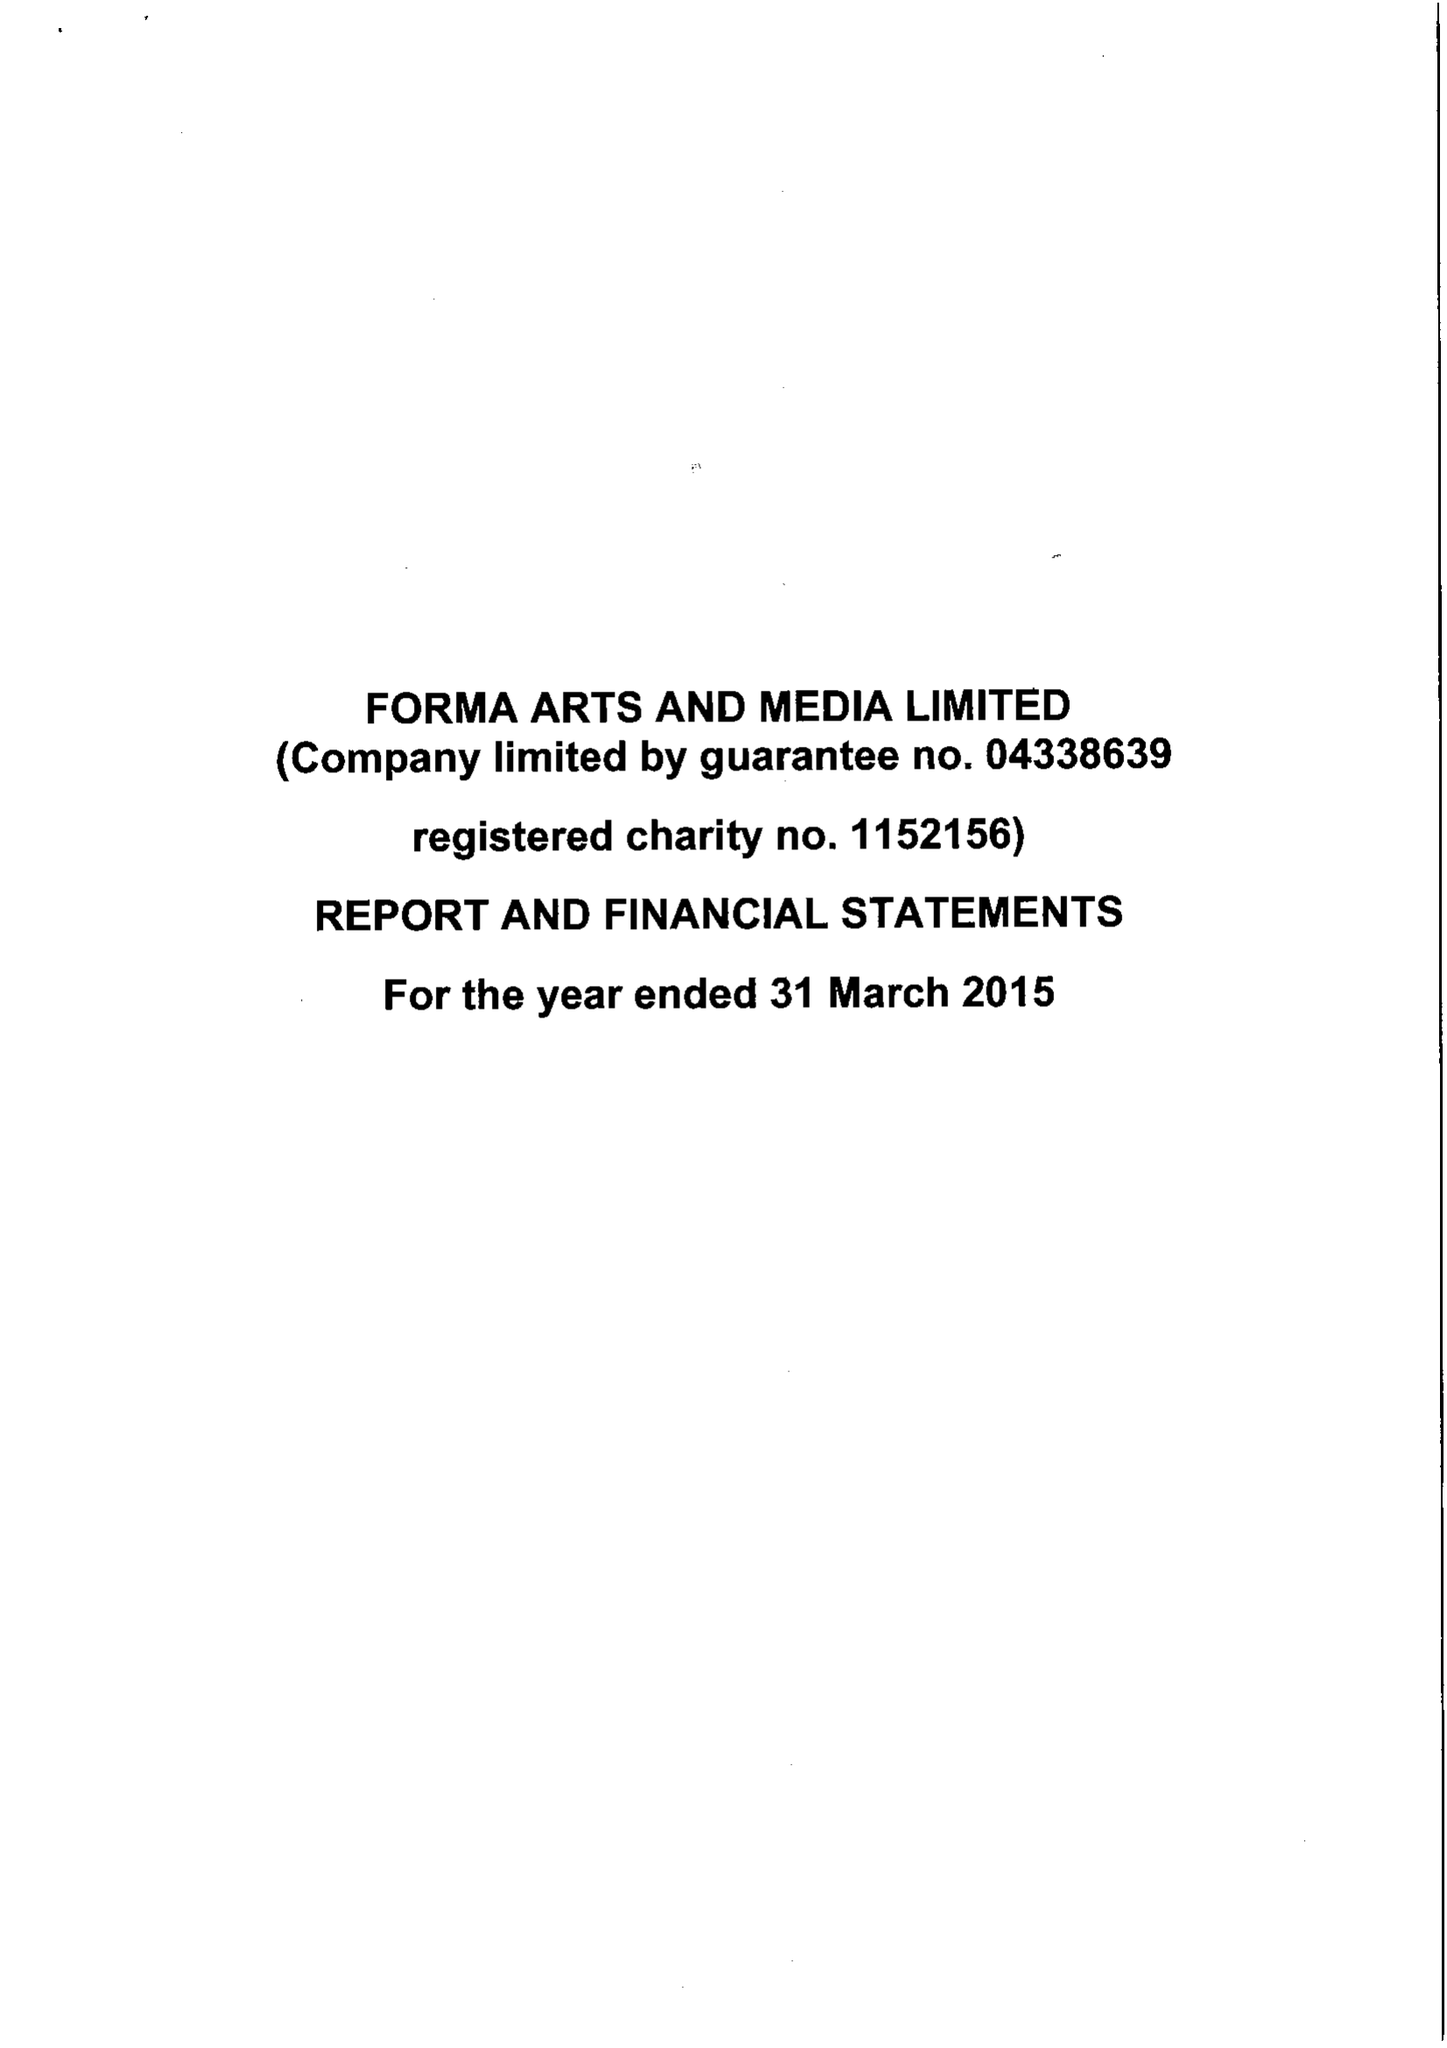What is the value for the charity_name?
Answer the question using a single word or phrase. Forma Arts and Media Ltd. 